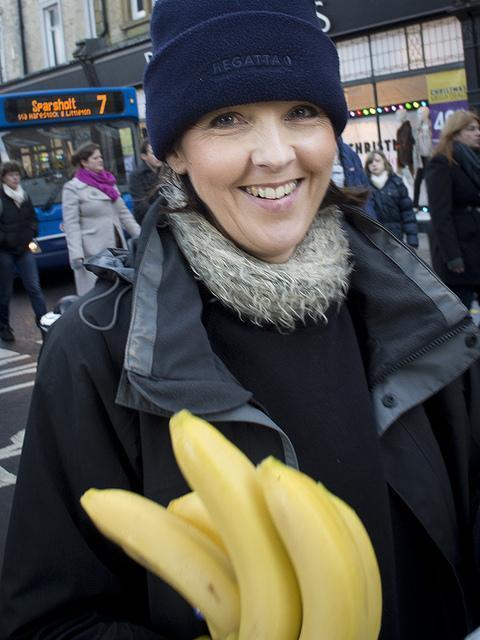The store behind the bus is having a sale due to which major event?
Select the accurate response from the four choices given to answer the question.
Options: Boxing day, halloween, labor day, christmas. Christmas. 